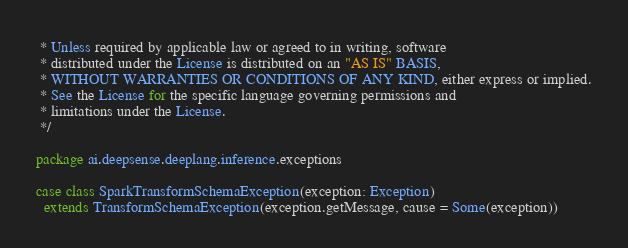Convert code to text. <code><loc_0><loc_0><loc_500><loc_500><_Scala_> * Unless required by applicable law or agreed to in writing, software
 * distributed under the License is distributed on an "AS IS" BASIS,
 * WITHOUT WARRANTIES OR CONDITIONS OF ANY KIND, either express or implied.
 * See the License for the specific language governing permissions and
 * limitations under the License.
 */

package ai.deepsense.deeplang.inference.exceptions

case class SparkTransformSchemaException(exception: Exception)
  extends TransformSchemaException(exception.getMessage, cause = Some(exception))
</code> 